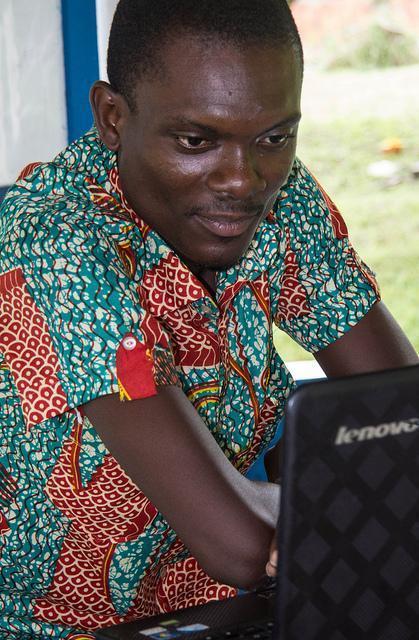How many wood chairs are tilted?
Give a very brief answer. 0. 